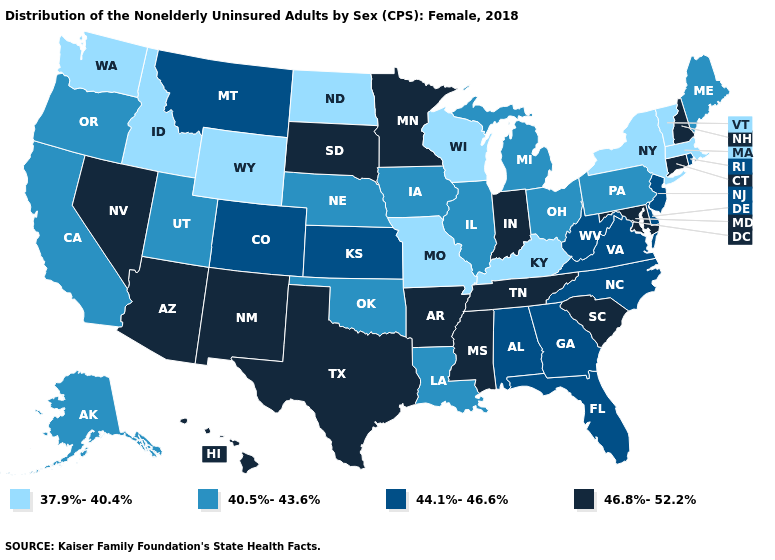Does South Dakota have the highest value in the MidWest?
Concise answer only. Yes. What is the highest value in the South ?
Keep it brief. 46.8%-52.2%. Does Indiana have the lowest value in the MidWest?
Write a very short answer. No. Name the states that have a value in the range 44.1%-46.6%?
Quick response, please. Alabama, Colorado, Delaware, Florida, Georgia, Kansas, Montana, New Jersey, North Carolina, Rhode Island, Virginia, West Virginia. What is the value of Wisconsin?
Be succinct. 37.9%-40.4%. What is the lowest value in the West?
Keep it brief. 37.9%-40.4%. What is the value of West Virginia?
Give a very brief answer. 44.1%-46.6%. Does the first symbol in the legend represent the smallest category?
Give a very brief answer. Yes. Among the states that border Rhode Island , does Connecticut have the highest value?
Give a very brief answer. Yes. Name the states that have a value in the range 46.8%-52.2%?
Concise answer only. Arizona, Arkansas, Connecticut, Hawaii, Indiana, Maryland, Minnesota, Mississippi, Nevada, New Hampshire, New Mexico, South Carolina, South Dakota, Tennessee, Texas. Which states hav the highest value in the Northeast?
Answer briefly. Connecticut, New Hampshire. Name the states that have a value in the range 40.5%-43.6%?
Give a very brief answer. Alaska, California, Illinois, Iowa, Louisiana, Maine, Michigan, Nebraska, Ohio, Oklahoma, Oregon, Pennsylvania, Utah. Name the states that have a value in the range 44.1%-46.6%?
Keep it brief. Alabama, Colorado, Delaware, Florida, Georgia, Kansas, Montana, New Jersey, North Carolina, Rhode Island, Virginia, West Virginia. Among the states that border California , does Oregon have the lowest value?
Short answer required. Yes. What is the value of South Dakota?
Give a very brief answer. 46.8%-52.2%. 